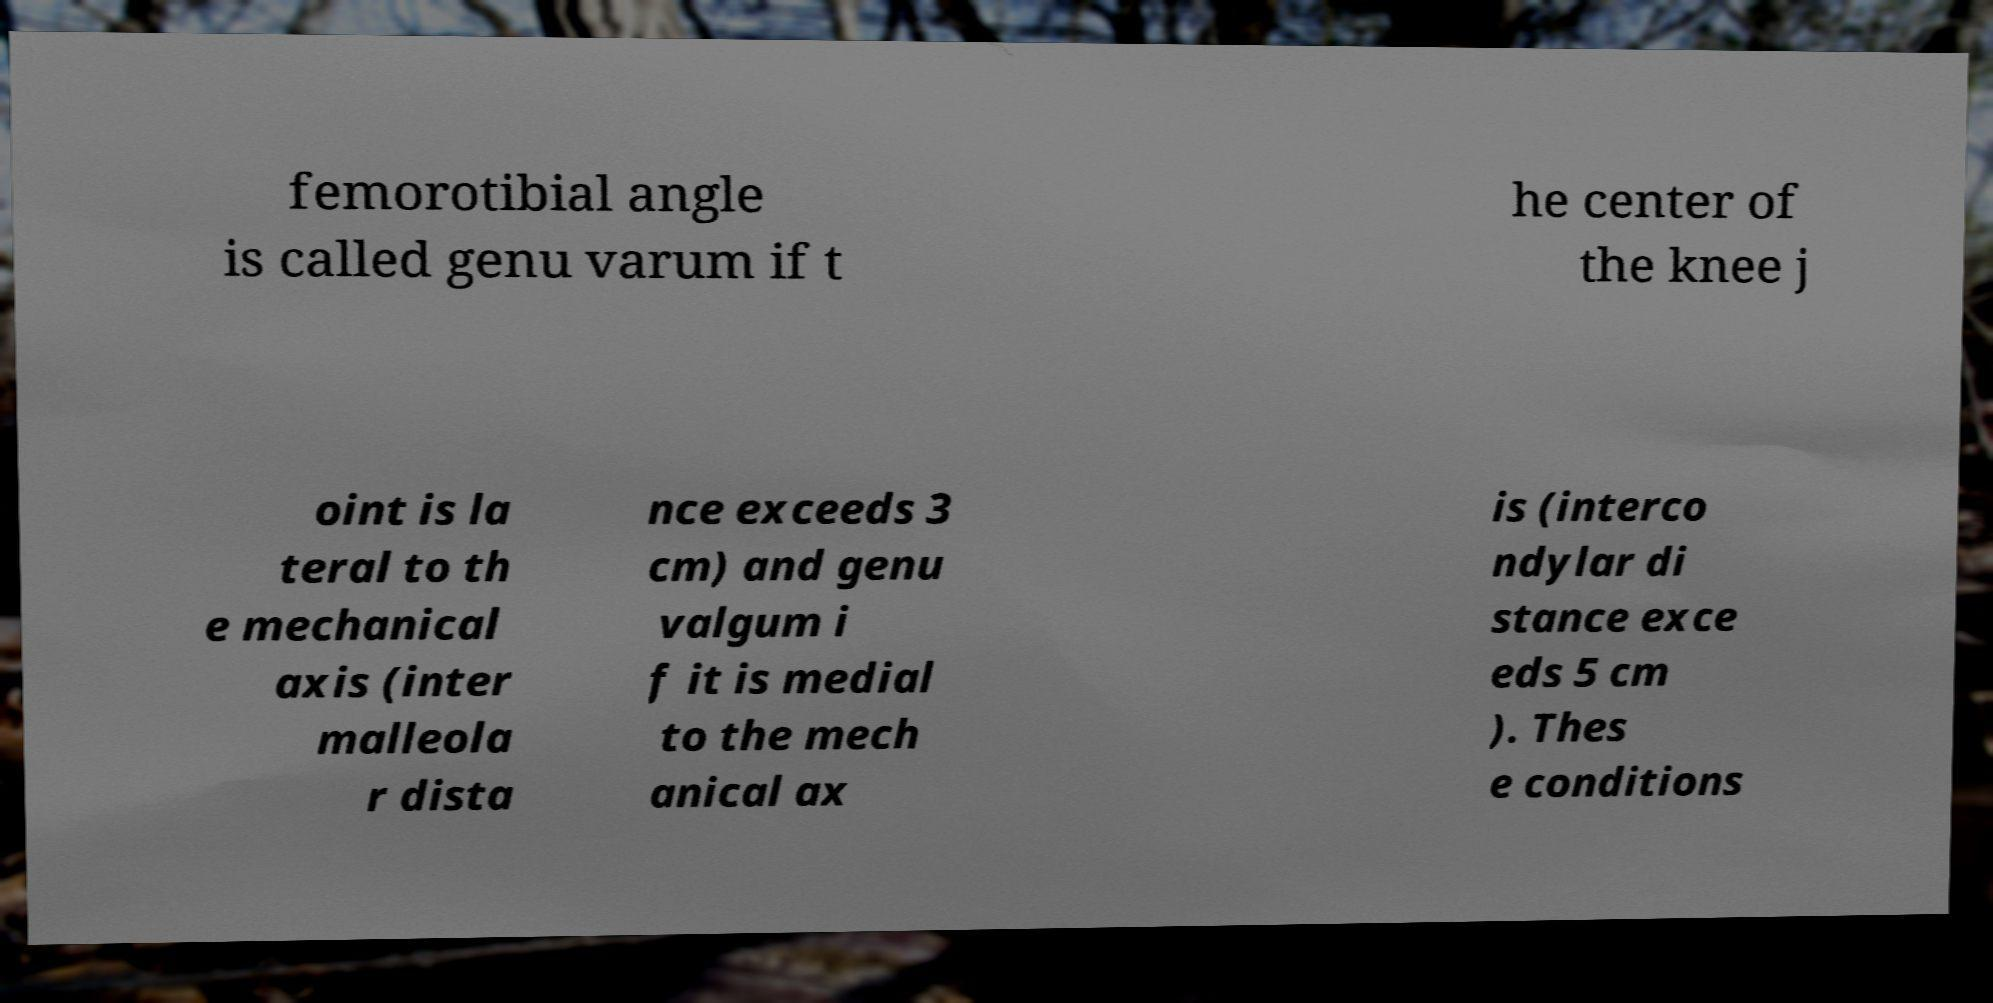Can you accurately transcribe the text from the provided image for me? femorotibial angle is called genu varum if t he center of the knee j oint is la teral to th e mechanical axis (inter malleola r dista nce exceeds 3 cm) and genu valgum i f it is medial to the mech anical ax is (interco ndylar di stance exce eds 5 cm ). Thes e conditions 